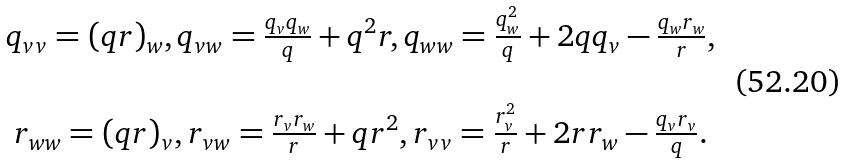<formula> <loc_0><loc_0><loc_500><loc_500>\begin{array} { c } q _ { v v } = ( q r ) _ { w } , q _ { v w } = \frac { q _ { v } q _ { w } } { q } + q ^ { 2 } r , q _ { w w } = \frac { q _ { w } ^ { 2 } } { q } + 2 q q _ { v } - \frac { q _ { w } r _ { w } } { r } , \\ \ \\ r _ { w w } = ( q r ) _ { v } , r _ { v w } = \frac { r _ { v } r _ { w } } { r } + q r ^ { 2 } , r _ { v v } = \frac { r _ { v } ^ { 2 } } { r } + 2 r r _ { w } - \frac { q _ { v } r _ { v } } { q } . \end{array}</formula> 